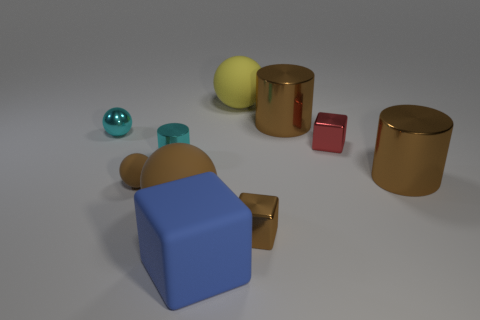Is the small metallic cylinder the same color as the tiny metal sphere?
Offer a very short reply. Yes. Are there any large matte objects that have the same color as the small matte ball?
Keep it short and to the point. Yes. What is the size of the shiny block that is the same color as the tiny rubber thing?
Keep it short and to the point. Small. The metal thing that is the same color as the small cylinder is what shape?
Provide a short and direct response. Sphere. How big is the cyan cylinder that is to the left of the matte thing that is behind the cylinder that is in front of the cyan cylinder?
Give a very brief answer. Small. What is the small cylinder made of?
Provide a short and direct response. Metal. Is the material of the big yellow sphere the same as the cylinder that is left of the large blue object?
Make the answer very short. No. Are there any other things of the same color as the tiny rubber sphere?
Ensure brevity in your answer.  Yes. There is a large ball to the right of the large matte object in front of the brown cube; is there a brown object that is in front of it?
Offer a very short reply. Yes. The rubber block is what color?
Your answer should be compact. Blue. 